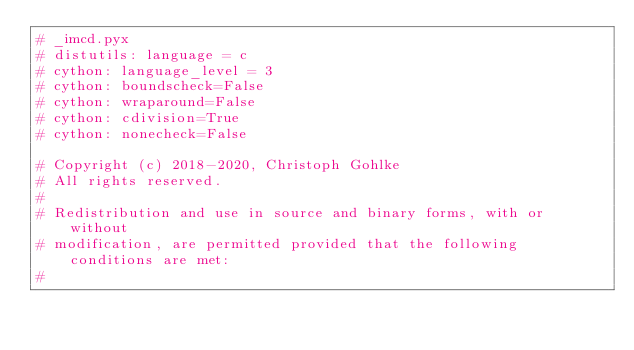Convert code to text. <code><loc_0><loc_0><loc_500><loc_500><_Cython_># _imcd.pyx
# distutils: language = c
# cython: language_level = 3
# cython: boundscheck=False
# cython: wraparound=False
# cython: cdivision=True
# cython: nonecheck=False

# Copyright (c) 2018-2020, Christoph Gohlke
# All rights reserved.
#
# Redistribution and use in source and binary forms, with or without
# modification, are permitted provided that the following conditions are met:
#</code> 